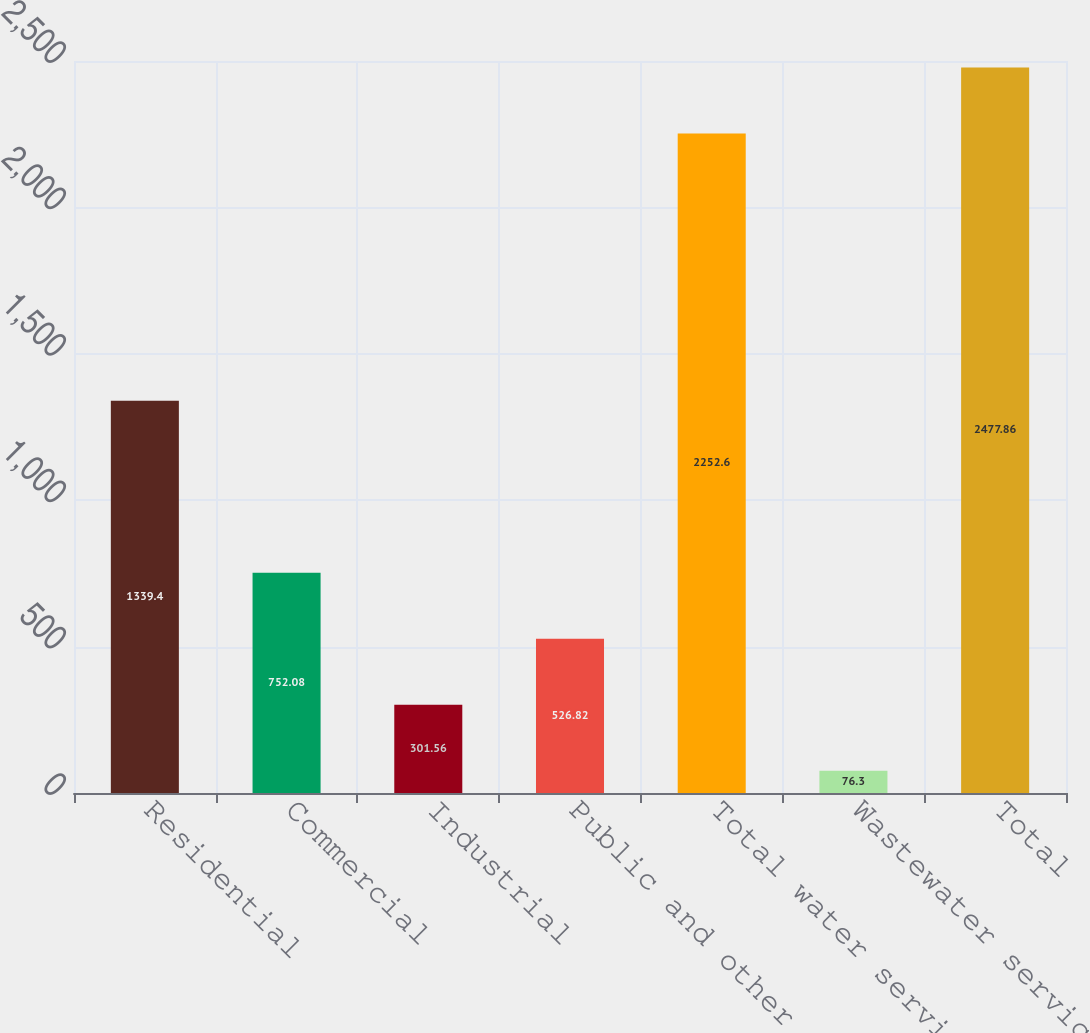<chart> <loc_0><loc_0><loc_500><loc_500><bar_chart><fcel>Residential<fcel>Commercial<fcel>Industrial<fcel>Public and other<fcel>Total water services<fcel>Wastewater services<fcel>Total<nl><fcel>1339.4<fcel>752.08<fcel>301.56<fcel>526.82<fcel>2252.6<fcel>76.3<fcel>2477.86<nl></chart> 